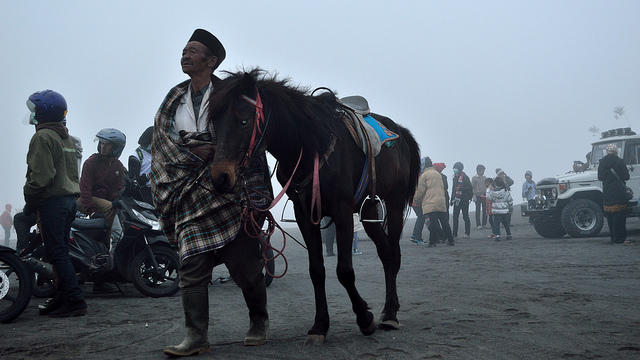<image>What color are the lead walker's shoelaces? It is ambiguous what color the lead walker's shoelaces are. They could either be black, brown, gray, white, or have no laces. What color is the taller boys shirt? I'm not sure about the color of the taller boy's shirt. It could be any color. What is the profession of the men in this photo? I don't know what the profession of the men in this photo. It could be caregiver, racer, groomer, or farmer. What color is the taller boys shirt? It is ambiguous what color is the taller boy's shirt. It can be seen white, blue, tan, green, red, black or unknown. What color are the lead walker's shoelaces? I don't know what color the lead walker's shoelaces are. It can be seen black, brown, white or gray. What is the profession of the men in this photo? I am not sure what the profession of the men in this photo is. It can be seen as 'caregiver', 'racer', 'groomer', 'farmer', 'trainer', 'horse caregiver', 'singer' or 'horse rider'. 